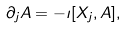<formula> <loc_0><loc_0><loc_500><loc_500>\partial _ { j } A = - \imath [ X _ { j } , A ] ,</formula> 